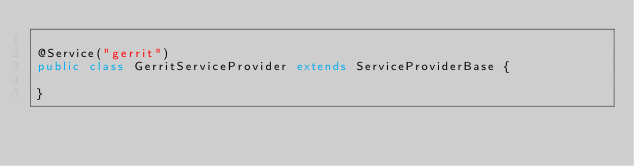Convert code to text. <code><loc_0><loc_0><loc_500><loc_500><_Java_>
@Service("gerrit")
public class GerritServiceProvider extends ServiceProviderBase {

}
</code> 